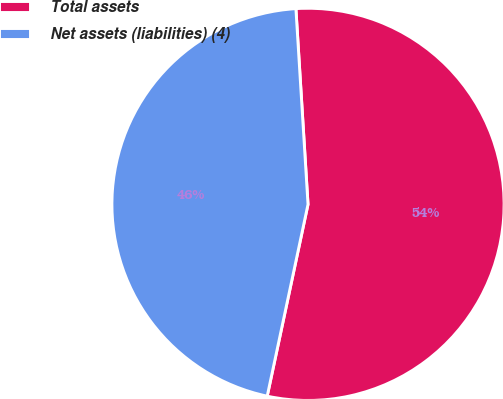<chart> <loc_0><loc_0><loc_500><loc_500><pie_chart><fcel>Total assets<fcel>Net assets (liabilities) (4)<nl><fcel>54.32%<fcel>45.68%<nl></chart> 